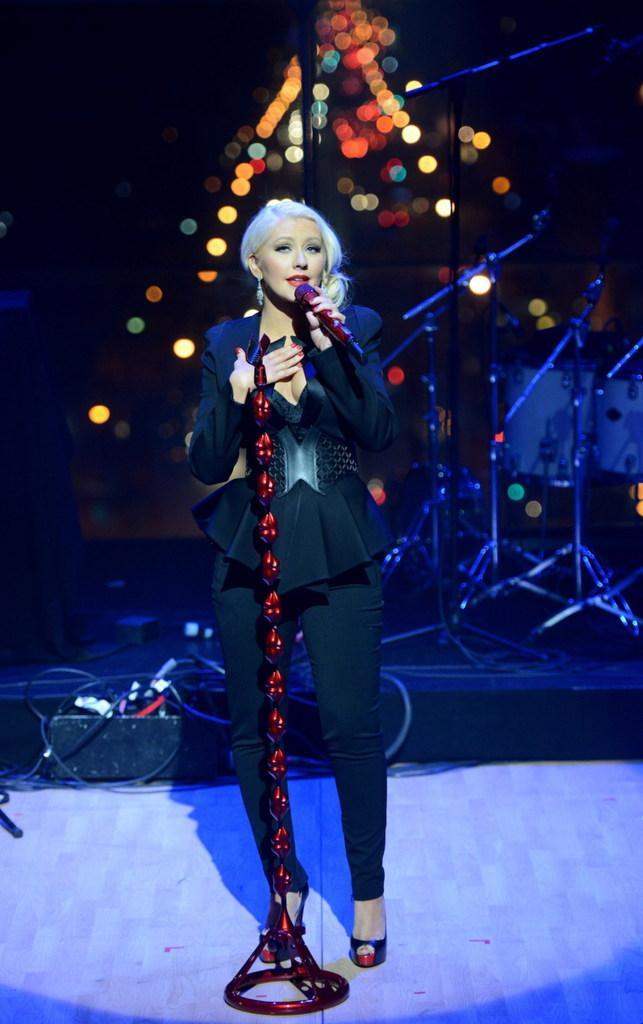Describe this image in one or two sentences. In the image we can see a woman standing, wearing clothes, earring and sandal, and she is holding a microphone in her hand. This is a cable wire and these are the microphone stand, the background is blurred. 